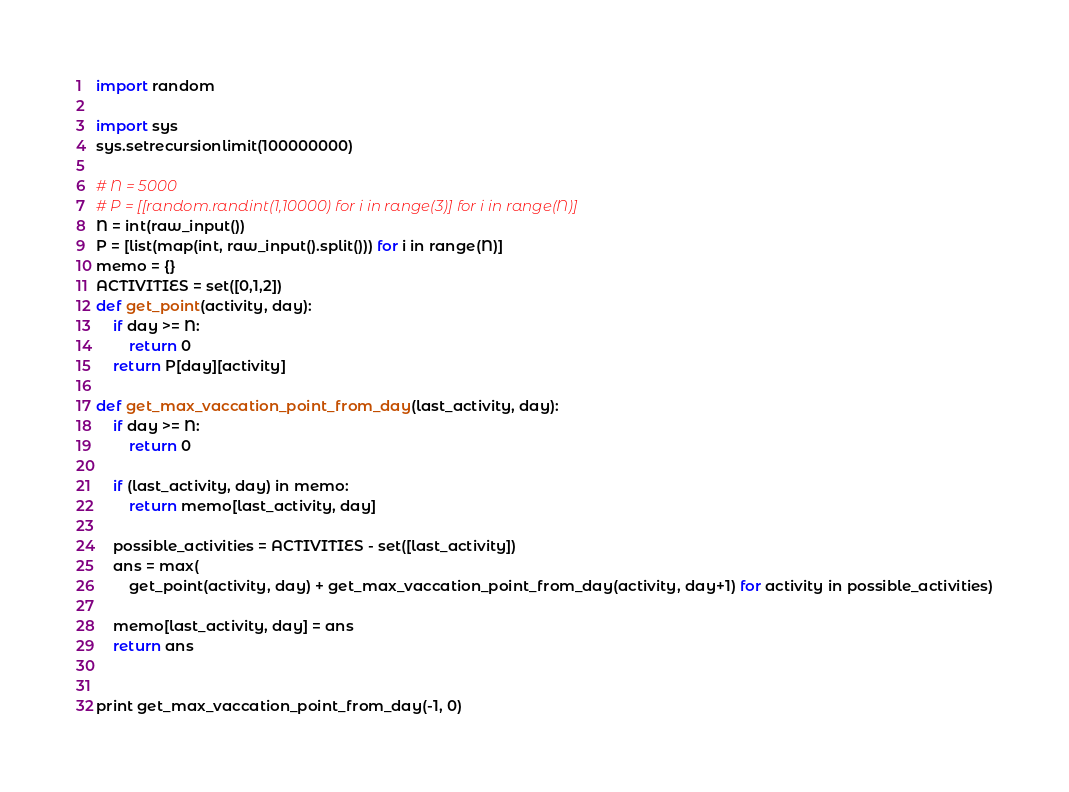Convert code to text. <code><loc_0><loc_0><loc_500><loc_500><_Python_>import random

import sys
sys.setrecursionlimit(100000000)

# N = 5000
# P = [[random.randint(1,10000) for i in range(3)] for i in range(N)]
N = int(raw_input())
P = [list(map(int, raw_input().split())) for i in range(N)]
memo = {}
ACTIVITIES = set([0,1,2])
def get_point(activity, day):
    if day >= N:
        return 0
    return P[day][activity]

def get_max_vaccation_point_from_day(last_activity, day):
    if day >= N:
        return 0

    if (last_activity, day) in memo:
        return memo[last_activity, day]

    possible_activities = ACTIVITIES - set([last_activity])
    ans = max(
        get_point(activity, day) + get_max_vaccation_point_from_day(activity, day+1) for activity in possible_activities)

    memo[last_activity, day] = ans
    return ans


print get_max_vaccation_point_from_day(-1, 0)
</code> 